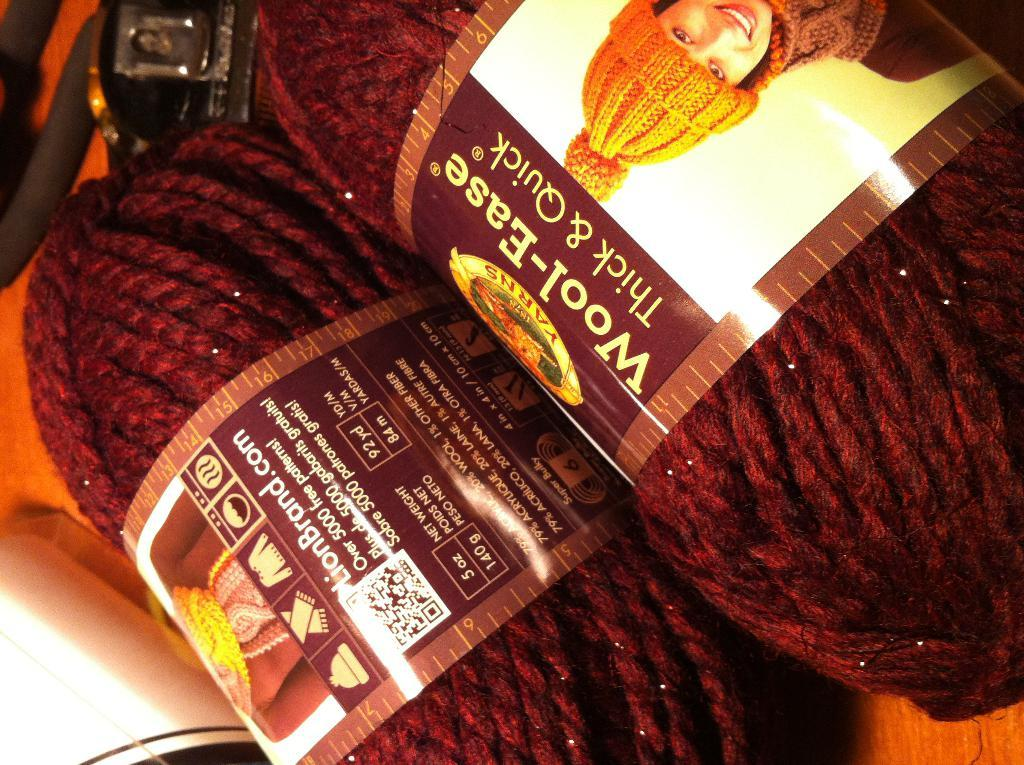What material is present in the image? There is wool in the image. Who is present in the image? There is a woman in the image. What is the woman wearing on her head? The woman is wearing a cap. What is the woman wearing on her body? The woman is wearing clothes. What additional object can be seen in the image? There is a sticker in the image. What type of prose is the woman teaching in the image? There is no indication in the image that the woman is teaching any type of prose. What facial expression does the woman have in the image? The image does not show the woman's face, so her facial expression cannot be determined. 